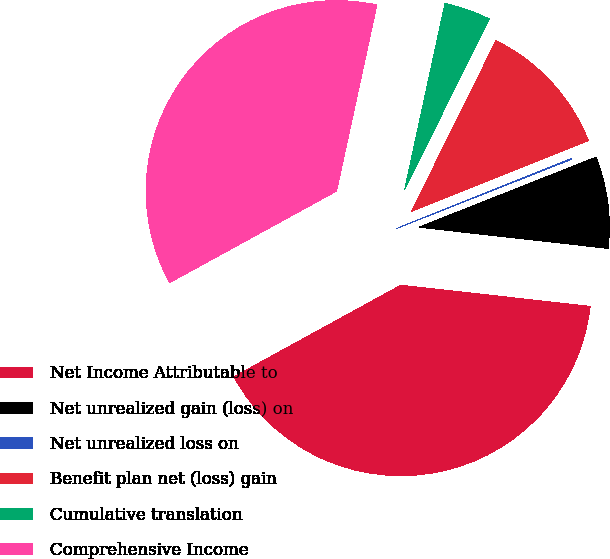<chart> <loc_0><loc_0><loc_500><loc_500><pie_chart><fcel>Net Income Attributable to<fcel>Net unrealized gain (loss) on<fcel>Net unrealized loss on<fcel>Benefit plan net (loss) gain<fcel>Cumulative translation<fcel>Comprehensive Income<nl><fcel>40.24%<fcel>7.77%<fcel>0.06%<fcel>11.63%<fcel>3.92%<fcel>36.38%<nl></chart> 